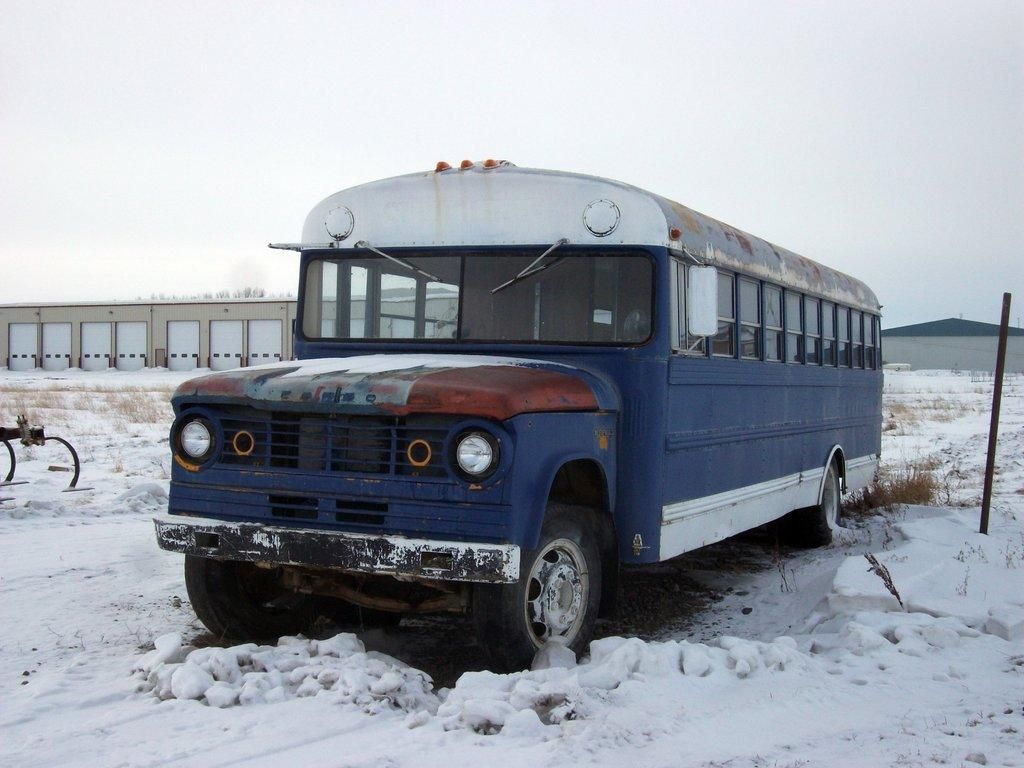What type of vehicle is in the image? There is a blue color bus in the image. Where is the bus located? The bus is on the road. What is the condition of the road in the image? The road is covered with snow. What can be seen in the background of the image? There is a house and the sky visible in the background of the image. How would you describe the sky in the image? The sky appears to be plain in the image. What type of yarn is being used to decorate the house in the image? There is no yarn present in the image, and the house is not being decorated. How many eggs can be seen in the image? There are no eggs visible in the image. 